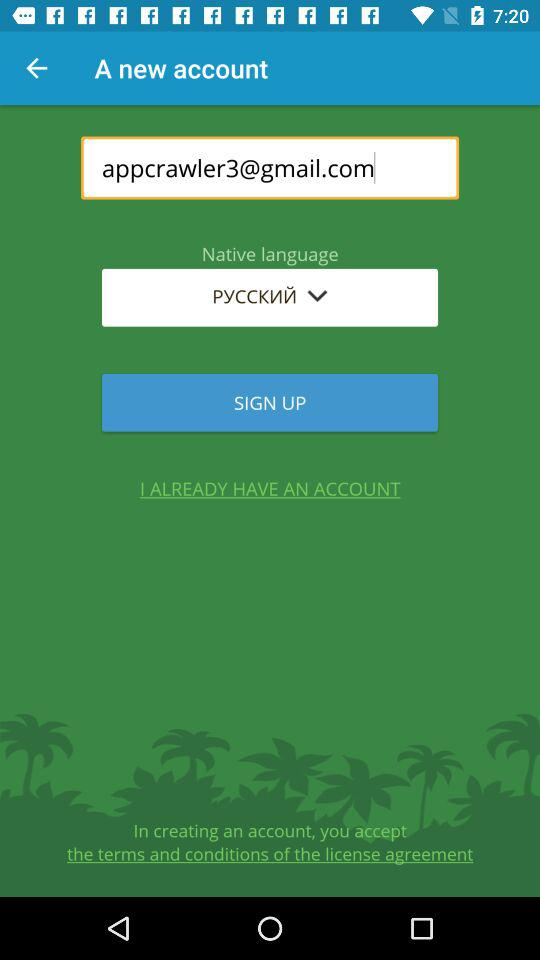What's the email address? The email address is appcrawler3@gmail.com. 